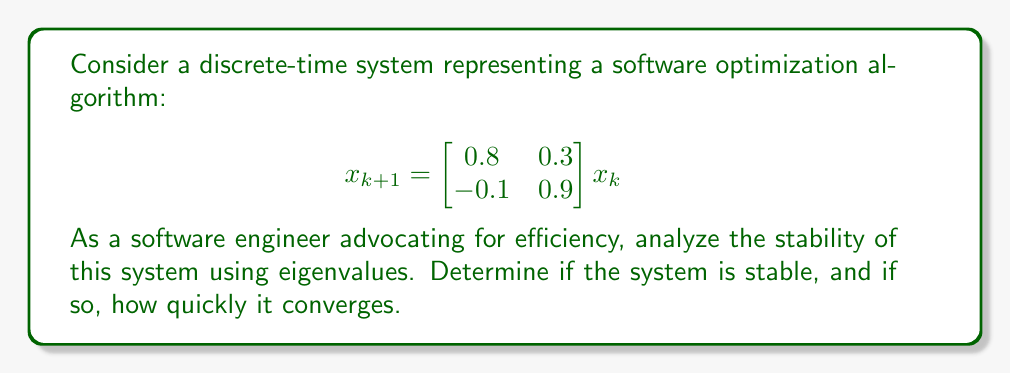Show me your answer to this math problem. To analyze the stability of this discrete-time system, we need to follow these steps:

1. Find the eigenvalues of the system matrix:
   $$A = \begin{bmatrix} 0.8 & 0.3 \\ -0.1 & 0.9 \end{bmatrix}$$

2. Calculate the characteristic equation:
   $$det(A - \lambda I) = \begin{vmatrix} 0.8 - \lambda & 0.3 \\ -0.1 & 0.9 - \lambda \end{vmatrix} = 0$$
   $$(0.8 - \lambda)(0.9 - \lambda) + 0.03 = 0$$
   $$\lambda^2 - 1.7\lambda + 0.75 = 0$$

3. Solve for the eigenvalues:
   Using the quadratic formula, we get:
   $$\lambda = \frac{1.7 \pm \sqrt{1.7^2 - 4(0.75)}}{2} = \frac{1.7 \pm \sqrt{2.89 - 3}}{2} = \frac{1.7 \pm 0.1}{2}$$
   $$\lambda_1 = 0.9, \lambda_2 = 0.8$$

4. Analyze stability:
   For a discrete-time system to be stable, all eigenvalues must lie within the unit circle in the complex plane, i.e., have magnitude less than 1.

   Here, both eigenvalues are real and positive:
   $|\lambda_1| = 0.9 < 1$
   $|\lambda_2| = 0.8 < 1$

   Since both eigenvalues have magnitude less than 1, the system is stable.

5. Convergence rate:
   The rate of convergence is determined by the largest eigenvalue in magnitude. In this case, it's $\lambda_1 = 0.9$.
   The system will converge at a rate of approximately $0.9^k$, where $k$ is the number of iterations.

From an efficiency perspective, this means that the optimization algorithm converges, but not extremely quickly. Each iteration reduces the error by about 10%.
Answer: Stable; converges at rate $\approx 0.9^k$ 